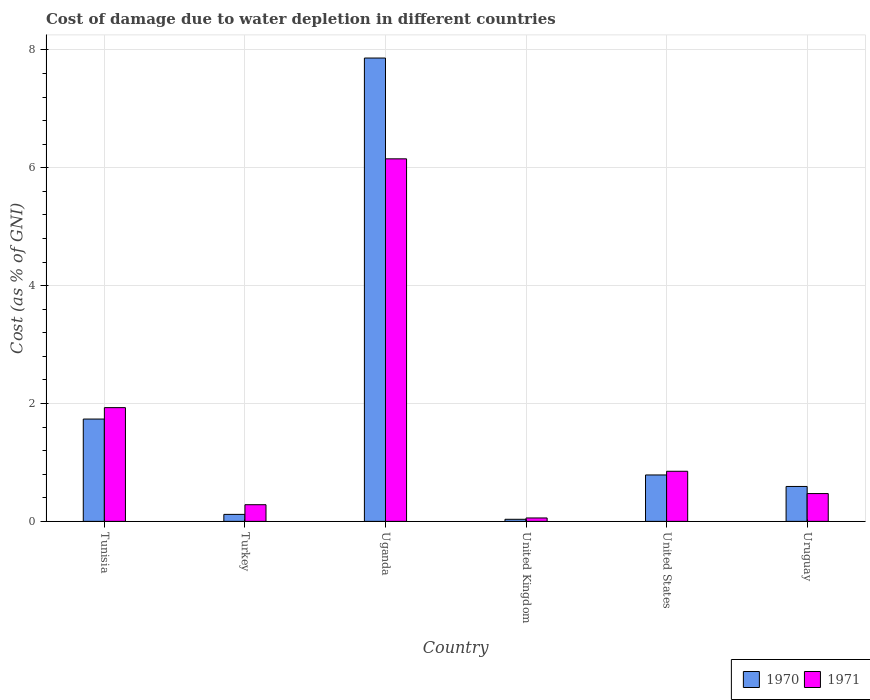How many different coloured bars are there?
Your answer should be compact. 2. How many bars are there on the 4th tick from the left?
Your response must be concise. 2. What is the cost of damage caused due to water depletion in 1971 in United Kingdom?
Give a very brief answer. 0.06. Across all countries, what is the maximum cost of damage caused due to water depletion in 1971?
Your response must be concise. 6.15. Across all countries, what is the minimum cost of damage caused due to water depletion in 1971?
Keep it short and to the point. 0.06. In which country was the cost of damage caused due to water depletion in 1971 maximum?
Provide a succinct answer. Uganda. What is the total cost of damage caused due to water depletion in 1971 in the graph?
Offer a terse response. 9.74. What is the difference between the cost of damage caused due to water depletion in 1971 in Tunisia and that in Uganda?
Offer a very short reply. -4.22. What is the difference between the cost of damage caused due to water depletion in 1971 in United States and the cost of damage caused due to water depletion in 1970 in United Kingdom?
Provide a short and direct response. 0.81. What is the average cost of damage caused due to water depletion in 1970 per country?
Your answer should be compact. 1.86. What is the difference between the cost of damage caused due to water depletion of/in 1970 and cost of damage caused due to water depletion of/in 1971 in United States?
Provide a short and direct response. -0.06. What is the ratio of the cost of damage caused due to water depletion in 1970 in Tunisia to that in United States?
Your response must be concise. 2.2. Is the cost of damage caused due to water depletion in 1970 in Tunisia less than that in Uruguay?
Your answer should be very brief. No. Is the difference between the cost of damage caused due to water depletion in 1970 in United Kingdom and Uruguay greater than the difference between the cost of damage caused due to water depletion in 1971 in United Kingdom and Uruguay?
Offer a terse response. No. What is the difference between the highest and the second highest cost of damage caused due to water depletion in 1970?
Offer a terse response. -0.95. What is the difference between the highest and the lowest cost of damage caused due to water depletion in 1971?
Provide a short and direct response. 6.09. In how many countries, is the cost of damage caused due to water depletion in 1970 greater than the average cost of damage caused due to water depletion in 1970 taken over all countries?
Provide a succinct answer. 1. What does the 2nd bar from the left in Uruguay represents?
Give a very brief answer. 1971. What does the 1st bar from the right in Tunisia represents?
Provide a short and direct response. 1971. How many countries are there in the graph?
Offer a very short reply. 6. What is the difference between two consecutive major ticks on the Y-axis?
Your response must be concise. 2. Are the values on the major ticks of Y-axis written in scientific E-notation?
Keep it short and to the point. No. Does the graph contain any zero values?
Provide a short and direct response. No. Where does the legend appear in the graph?
Your answer should be very brief. Bottom right. How are the legend labels stacked?
Your response must be concise. Horizontal. What is the title of the graph?
Make the answer very short. Cost of damage due to water depletion in different countries. Does "1968" appear as one of the legend labels in the graph?
Provide a succinct answer. No. What is the label or title of the X-axis?
Ensure brevity in your answer.  Country. What is the label or title of the Y-axis?
Offer a terse response. Cost (as % of GNI). What is the Cost (as % of GNI) in 1970 in Tunisia?
Keep it short and to the point. 1.74. What is the Cost (as % of GNI) of 1971 in Tunisia?
Your answer should be very brief. 1.93. What is the Cost (as % of GNI) in 1970 in Turkey?
Make the answer very short. 0.12. What is the Cost (as % of GNI) of 1971 in Turkey?
Give a very brief answer. 0.28. What is the Cost (as % of GNI) in 1970 in Uganda?
Make the answer very short. 7.86. What is the Cost (as % of GNI) in 1971 in Uganda?
Provide a succinct answer. 6.15. What is the Cost (as % of GNI) in 1970 in United Kingdom?
Make the answer very short. 0.04. What is the Cost (as % of GNI) of 1971 in United Kingdom?
Give a very brief answer. 0.06. What is the Cost (as % of GNI) in 1970 in United States?
Make the answer very short. 0.79. What is the Cost (as % of GNI) of 1971 in United States?
Ensure brevity in your answer.  0.85. What is the Cost (as % of GNI) of 1970 in Uruguay?
Your answer should be compact. 0.59. What is the Cost (as % of GNI) of 1971 in Uruguay?
Keep it short and to the point. 0.47. Across all countries, what is the maximum Cost (as % of GNI) in 1970?
Ensure brevity in your answer.  7.86. Across all countries, what is the maximum Cost (as % of GNI) in 1971?
Offer a terse response. 6.15. Across all countries, what is the minimum Cost (as % of GNI) in 1970?
Provide a succinct answer. 0.04. Across all countries, what is the minimum Cost (as % of GNI) in 1971?
Provide a short and direct response. 0.06. What is the total Cost (as % of GNI) in 1970 in the graph?
Keep it short and to the point. 11.13. What is the total Cost (as % of GNI) in 1971 in the graph?
Your answer should be very brief. 9.74. What is the difference between the Cost (as % of GNI) of 1970 in Tunisia and that in Turkey?
Your response must be concise. 1.62. What is the difference between the Cost (as % of GNI) of 1971 in Tunisia and that in Turkey?
Ensure brevity in your answer.  1.65. What is the difference between the Cost (as % of GNI) of 1970 in Tunisia and that in Uganda?
Your answer should be compact. -6.13. What is the difference between the Cost (as % of GNI) in 1971 in Tunisia and that in Uganda?
Give a very brief answer. -4.22. What is the difference between the Cost (as % of GNI) of 1970 in Tunisia and that in United Kingdom?
Provide a succinct answer. 1.7. What is the difference between the Cost (as % of GNI) in 1971 in Tunisia and that in United Kingdom?
Your answer should be very brief. 1.87. What is the difference between the Cost (as % of GNI) of 1970 in Tunisia and that in United States?
Give a very brief answer. 0.95. What is the difference between the Cost (as % of GNI) of 1971 in Tunisia and that in United States?
Provide a short and direct response. 1.08. What is the difference between the Cost (as % of GNI) in 1970 in Tunisia and that in Uruguay?
Your response must be concise. 1.14. What is the difference between the Cost (as % of GNI) in 1971 in Tunisia and that in Uruguay?
Make the answer very short. 1.46. What is the difference between the Cost (as % of GNI) in 1970 in Turkey and that in Uganda?
Provide a short and direct response. -7.74. What is the difference between the Cost (as % of GNI) of 1971 in Turkey and that in Uganda?
Keep it short and to the point. -5.87. What is the difference between the Cost (as % of GNI) of 1970 in Turkey and that in United Kingdom?
Ensure brevity in your answer.  0.08. What is the difference between the Cost (as % of GNI) in 1971 in Turkey and that in United Kingdom?
Keep it short and to the point. 0.22. What is the difference between the Cost (as % of GNI) in 1970 in Turkey and that in United States?
Ensure brevity in your answer.  -0.67. What is the difference between the Cost (as % of GNI) of 1971 in Turkey and that in United States?
Give a very brief answer. -0.57. What is the difference between the Cost (as % of GNI) of 1970 in Turkey and that in Uruguay?
Provide a succinct answer. -0.47. What is the difference between the Cost (as % of GNI) of 1971 in Turkey and that in Uruguay?
Ensure brevity in your answer.  -0.19. What is the difference between the Cost (as % of GNI) of 1970 in Uganda and that in United Kingdom?
Your answer should be compact. 7.83. What is the difference between the Cost (as % of GNI) in 1971 in Uganda and that in United Kingdom?
Offer a very short reply. 6.09. What is the difference between the Cost (as % of GNI) of 1970 in Uganda and that in United States?
Give a very brief answer. 7.07. What is the difference between the Cost (as % of GNI) in 1971 in Uganda and that in United States?
Provide a succinct answer. 5.3. What is the difference between the Cost (as % of GNI) of 1970 in Uganda and that in Uruguay?
Ensure brevity in your answer.  7.27. What is the difference between the Cost (as % of GNI) of 1971 in Uganda and that in Uruguay?
Ensure brevity in your answer.  5.68. What is the difference between the Cost (as % of GNI) of 1970 in United Kingdom and that in United States?
Your answer should be very brief. -0.75. What is the difference between the Cost (as % of GNI) of 1971 in United Kingdom and that in United States?
Make the answer very short. -0.79. What is the difference between the Cost (as % of GNI) of 1970 in United Kingdom and that in Uruguay?
Provide a short and direct response. -0.56. What is the difference between the Cost (as % of GNI) in 1971 in United Kingdom and that in Uruguay?
Your answer should be very brief. -0.41. What is the difference between the Cost (as % of GNI) of 1970 in United States and that in Uruguay?
Keep it short and to the point. 0.2. What is the difference between the Cost (as % of GNI) of 1971 in United States and that in Uruguay?
Give a very brief answer. 0.38. What is the difference between the Cost (as % of GNI) of 1970 in Tunisia and the Cost (as % of GNI) of 1971 in Turkey?
Provide a succinct answer. 1.45. What is the difference between the Cost (as % of GNI) in 1970 in Tunisia and the Cost (as % of GNI) in 1971 in Uganda?
Make the answer very short. -4.42. What is the difference between the Cost (as % of GNI) in 1970 in Tunisia and the Cost (as % of GNI) in 1971 in United Kingdom?
Keep it short and to the point. 1.68. What is the difference between the Cost (as % of GNI) of 1970 in Tunisia and the Cost (as % of GNI) of 1971 in United States?
Give a very brief answer. 0.89. What is the difference between the Cost (as % of GNI) in 1970 in Tunisia and the Cost (as % of GNI) in 1971 in Uruguay?
Ensure brevity in your answer.  1.26. What is the difference between the Cost (as % of GNI) in 1970 in Turkey and the Cost (as % of GNI) in 1971 in Uganda?
Your answer should be very brief. -6.03. What is the difference between the Cost (as % of GNI) of 1970 in Turkey and the Cost (as % of GNI) of 1971 in United Kingdom?
Keep it short and to the point. 0.06. What is the difference between the Cost (as % of GNI) in 1970 in Turkey and the Cost (as % of GNI) in 1971 in United States?
Keep it short and to the point. -0.73. What is the difference between the Cost (as % of GNI) of 1970 in Turkey and the Cost (as % of GNI) of 1971 in Uruguay?
Make the answer very short. -0.35. What is the difference between the Cost (as % of GNI) in 1970 in Uganda and the Cost (as % of GNI) in 1971 in United Kingdom?
Your answer should be compact. 7.8. What is the difference between the Cost (as % of GNI) in 1970 in Uganda and the Cost (as % of GNI) in 1971 in United States?
Provide a succinct answer. 7.01. What is the difference between the Cost (as % of GNI) in 1970 in Uganda and the Cost (as % of GNI) in 1971 in Uruguay?
Offer a terse response. 7.39. What is the difference between the Cost (as % of GNI) in 1970 in United Kingdom and the Cost (as % of GNI) in 1971 in United States?
Your answer should be compact. -0.81. What is the difference between the Cost (as % of GNI) of 1970 in United Kingdom and the Cost (as % of GNI) of 1971 in Uruguay?
Your response must be concise. -0.44. What is the difference between the Cost (as % of GNI) of 1970 in United States and the Cost (as % of GNI) of 1971 in Uruguay?
Provide a succinct answer. 0.32. What is the average Cost (as % of GNI) in 1970 per country?
Provide a succinct answer. 1.86. What is the average Cost (as % of GNI) of 1971 per country?
Provide a short and direct response. 1.62. What is the difference between the Cost (as % of GNI) of 1970 and Cost (as % of GNI) of 1971 in Tunisia?
Ensure brevity in your answer.  -0.19. What is the difference between the Cost (as % of GNI) in 1970 and Cost (as % of GNI) in 1971 in Turkey?
Keep it short and to the point. -0.16. What is the difference between the Cost (as % of GNI) in 1970 and Cost (as % of GNI) in 1971 in Uganda?
Offer a very short reply. 1.71. What is the difference between the Cost (as % of GNI) of 1970 and Cost (as % of GNI) of 1971 in United Kingdom?
Your answer should be compact. -0.02. What is the difference between the Cost (as % of GNI) in 1970 and Cost (as % of GNI) in 1971 in United States?
Your answer should be compact. -0.06. What is the difference between the Cost (as % of GNI) in 1970 and Cost (as % of GNI) in 1971 in Uruguay?
Keep it short and to the point. 0.12. What is the ratio of the Cost (as % of GNI) in 1970 in Tunisia to that in Turkey?
Offer a terse response. 14.65. What is the ratio of the Cost (as % of GNI) in 1971 in Tunisia to that in Turkey?
Your answer should be compact. 6.83. What is the ratio of the Cost (as % of GNI) of 1970 in Tunisia to that in Uganda?
Your answer should be very brief. 0.22. What is the ratio of the Cost (as % of GNI) of 1971 in Tunisia to that in Uganda?
Provide a succinct answer. 0.31. What is the ratio of the Cost (as % of GNI) of 1970 in Tunisia to that in United Kingdom?
Offer a very short reply. 49.48. What is the ratio of the Cost (as % of GNI) in 1971 in Tunisia to that in United Kingdom?
Make the answer very short. 33.45. What is the ratio of the Cost (as % of GNI) in 1970 in Tunisia to that in United States?
Provide a succinct answer. 2.2. What is the ratio of the Cost (as % of GNI) in 1971 in Tunisia to that in United States?
Offer a very short reply. 2.27. What is the ratio of the Cost (as % of GNI) of 1970 in Tunisia to that in Uruguay?
Give a very brief answer. 2.93. What is the ratio of the Cost (as % of GNI) in 1971 in Tunisia to that in Uruguay?
Offer a very short reply. 4.09. What is the ratio of the Cost (as % of GNI) in 1970 in Turkey to that in Uganda?
Provide a short and direct response. 0.02. What is the ratio of the Cost (as % of GNI) in 1971 in Turkey to that in Uganda?
Your response must be concise. 0.05. What is the ratio of the Cost (as % of GNI) of 1970 in Turkey to that in United Kingdom?
Provide a short and direct response. 3.38. What is the ratio of the Cost (as % of GNI) in 1971 in Turkey to that in United Kingdom?
Offer a very short reply. 4.9. What is the ratio of the Cost (as % of GNI) in 1970 in Turkey to that in United States?
Offer a very short reply. 0.15. What is the ratio of the Cost (as % of GNI) of 1971 in Turkey to that in United States?
Give a very brief answer. 0.33. What is the ratio of the Cost (as % of GNI) in 1970 in Turkey to that in Uruguay?
Provide a succinct answer. 0.2. What is the ratio of the Cost (as % of GNI) in 1971 in Turkey to that in Uruguay?
Provide a short and direct response. 0.6. What is the ratio of the Cost (as % of GNI) of 1970 in Uganda to that in United Kingdom?
Your response must be concise. 224.06. What is the ratio of the Cost (as % of GNI) of 1971 in Uganda to that in United Kingdom?
Your answer should be very brief. 106.62. What is the ratio of the Cost (as % of GNI) in 1970 in Uganda to that in United States?
Provide a short and direct response. 9.98. What is the ratio of the Cost (as % of GNI) of 1971 in Uganda to that in United States?
Your response must be concise. 7.24. What is the ratio of the Cost (as % of GNI) in 1970 in Uganda to that in Uruguay?
Offer a terse response. 13.27. What is the ratio of the Cost (as % of GNI) in 1971 in Uganda to that in Uruguay?
Offer a very short reply. 13.05. What is the ratio of the Cost (as % of GNI) of 1970 in United Kingdom to that in United States?
Your answer should be very brief. 0.04. What is the ratio of the Cost (as % of GNI) in 1971 in United Kingdom to that in United States?
Your response must be concise. 0.07. What is the ratio of the Cost (as % of GNI) in 1970 in United Kingdom to that in Uruguay?
Ensure brevity in your answer.  0.06. What is the ratio of the Cost (as % of GNI) in 1971 in United Kingdom to that in Uruguay?
Provide a succinct answer. 0.12. What is the ratio of the Cost (as % of GNI) in 1970 in United States to that in Uruguay?
Provide a succinct answer. 1.33. What is the ratio of the Cost (as % of GNI) in 1971 in United States to that in Uruguay?
Your answer should be compact. 1.8. What is the difference between the highest and the second highest Cost (as % of GNI) in 1970?
Provide a succinct answer. 6.13. What is the difference between the highest and the second highest Cost (as % of GNI) in 1971?
Offer a very short reply. 4.22. What is the difference between the highest and the lowest Cost (as % of GNI) in 1970?
Give a very brief answer. 7.83. What is the difference between the highest and the lowest Cost (as % of GNI) in 1971?
Your answer should be compact. 6.09. 